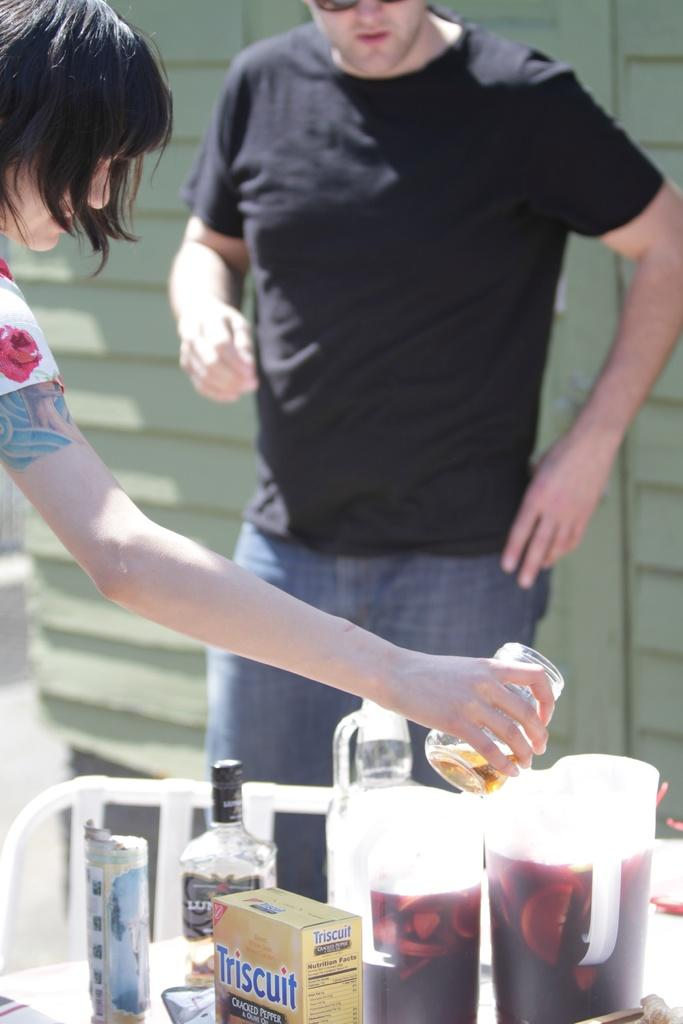How many people are in the image? There are two persons in the image. What is one of the persons holding? One of the persons is holding a glass with her hand. What is present on the table in the image? There are jars, bottles, and boxes on the table. What can be seen in the background of the image? There is a wall in the background of the image. What type of secretary is sitting on the throne in the image? There is no secretary or throne present in the image. What is the person attempting to do with the glass in the image? The person holding the glass is not attempting to do anything specific with it in the image; they are simply holding it. 